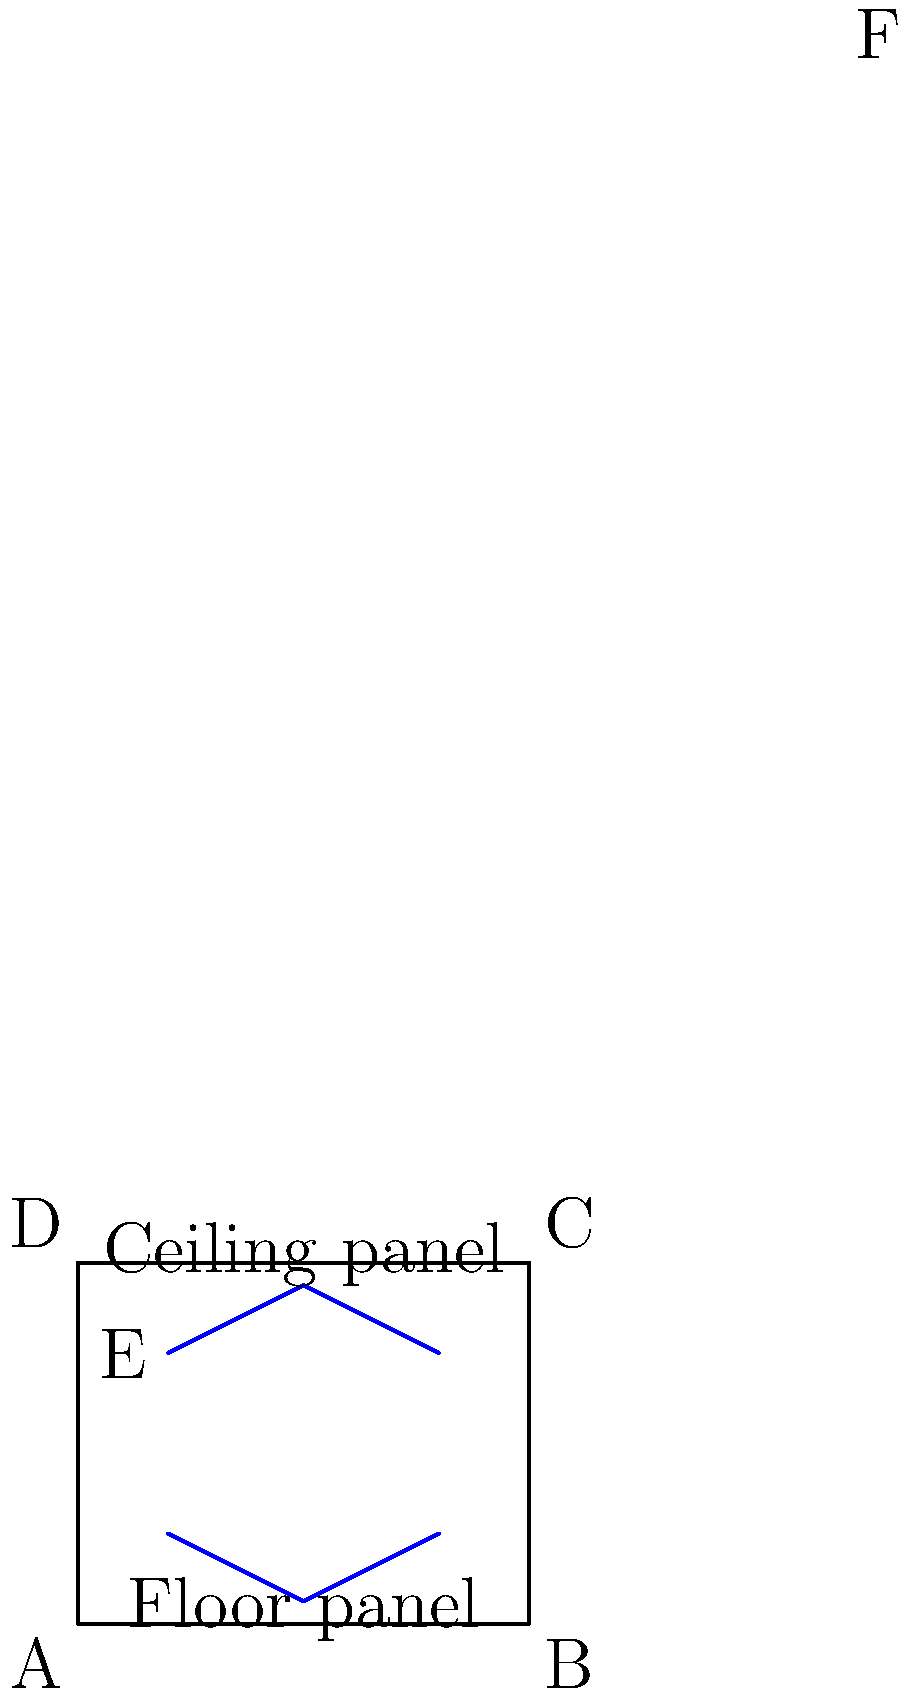In the cross-section of a concert hall shown above, two acoustic panels are visible: one on the ceiling and one on the floor. How does the curved shape of these panels contribute to the structural integrity and acoustic performance of the hall? Consider the distribution of forces and sound reflection patterns in your analysis. To analyze the structural integrity and acoustic performance of the curved acoustic panels, we need to consider both engineering and acoustic principles:

1. Structural Integrity:
   a) The curved shape of the panels creates an arch-like structure, which is inherently stronger than a flat panel.
   b) Arches distribute forces along their curve, redirecting the load to the supports at the ends.
   c) This distribution of forces reduces the bending moment in the center of the panel, making it more resistant to deformation.

2. Force Distribution:
   a) The curved shape allows for a more even distribution of the panel's weight and any additional loads.
   b) This even distribution reduces stress concentrations that could lead to structural weaknesses.

3. Acoustic Performance:
   a) The curved shape helps to diffuse sound waves, preventing echo and standing waves.
   b) Convex surfaces (as seen in both panels) scatter sound in multiple directions, creating a more even sound distribution throughout the hall.
   c) The curvature can be designed to focus sound towards the audience, improving clarity and volume.

4. Sound Reflection Patterns:
   a) The ceiling panel's curve helps to reflect sound downwards towards the audience.
   b) The floor panel's curve can help to reflect sound upwards, filling the space more evenly.
   c) The combination of these reflection patterns can create a more immersive and balanced acoustic environment.

5. Material Considerations:
   a) The curved shape allows for the use of thinner materials while maintaining structural integrity.
   b) This can result in lighter panels that are easier to install and maintain.

6. Resonance Control:
   a) The curved shape can help to break up sound waves of specific frequencies.
   b) This can be particularly useful in controlling unwanted resonances in the hall.

In conclusion, the curved shape of the acoustic panels contributes significantly to both the structural integrity and acoustic performance of the concert hall by efficiently distributing forces, diffusing sound waves, and creating optimal reflection patterns for a superior listening experience.
Answer: The curved shape enhances structural strength through arch-like force distribution and improves acoustics by diffusing sound waves and optimizing reflection patterns. 